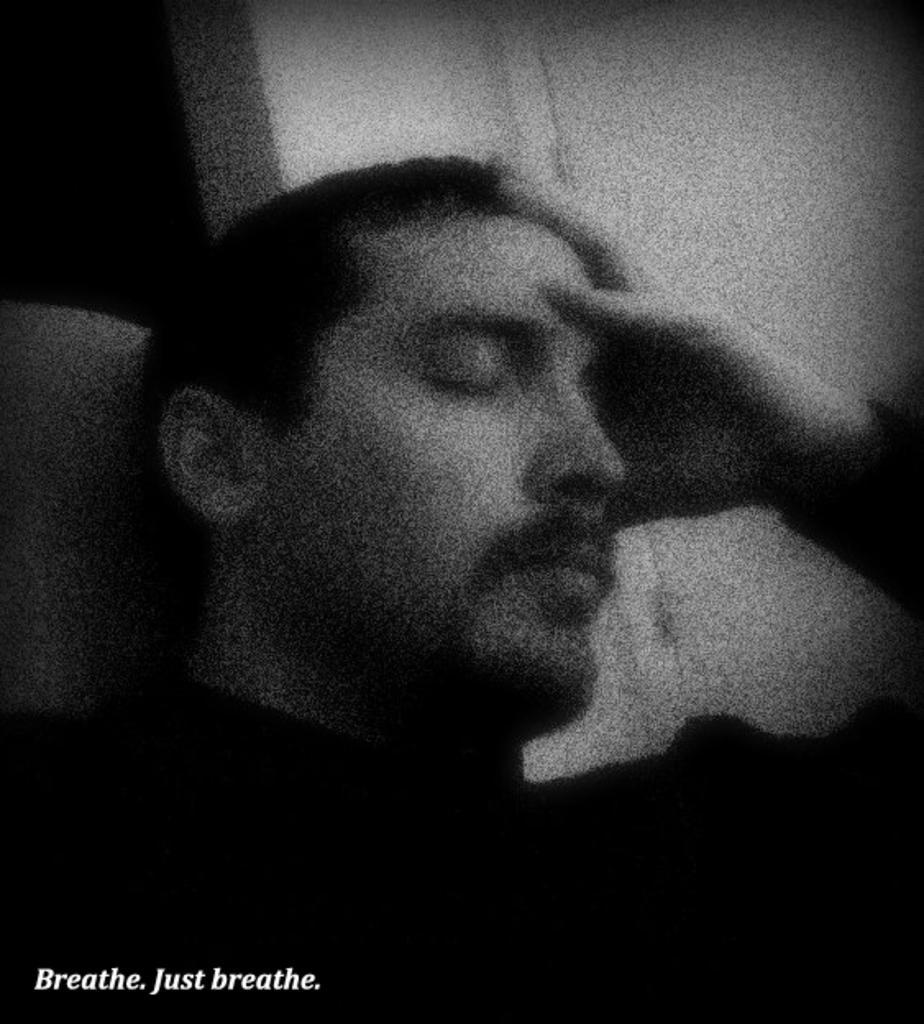Describe this image in one or two sentences. In this image I can observe a person in the middle of the picture. The image is in black and white. In the bottom left hand corner there is a text. 